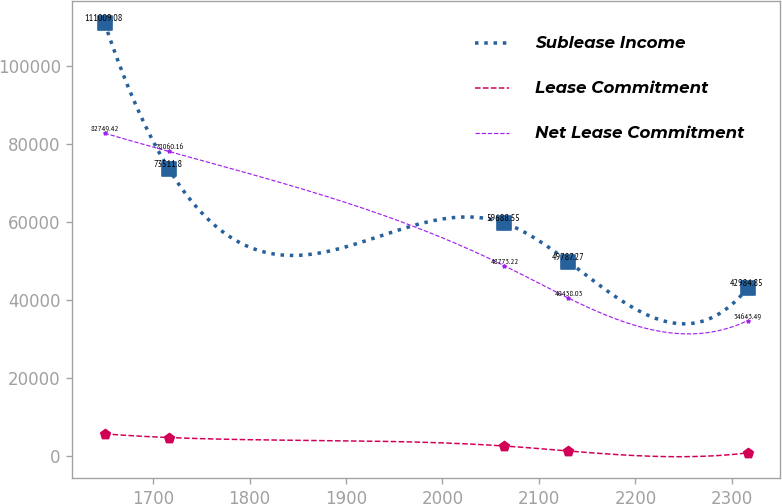Convert chart to OTSL. <chart><loc_0><loc_0><loc_500><loc_500><line_chart><ecel><fcel>Sublease Income<fcel>Lease Commitment<fcel>Net Lease Commitment<nl><fcel>1649.85<fcel>111009<fcel>5607.75<fcel>82749.4<nl><fcel>1716.48<fcel>73511.8<fcel>4666.31<fcel>78060.2<nl><fcel>2063.88<fcel>59688.6<fcel>2497.09<fcel>48773.2<nl><fcel>2130.51<fcel>49787.3<fcel>1214.89<fcel>40438<nl><fcel>2316.13<fcel>42984.8<fcel>722.83<fcel>34643.5<nl></chart> 